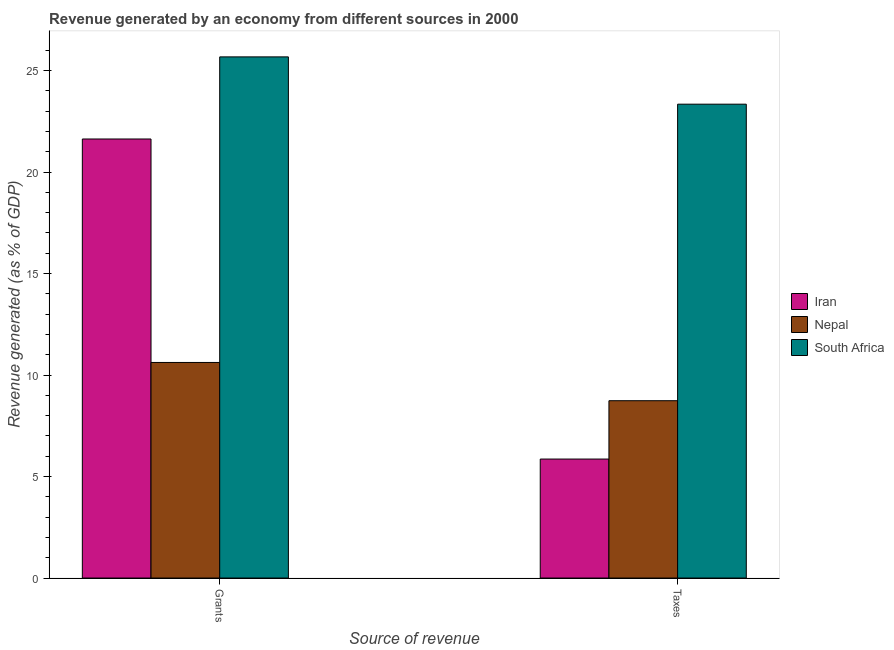Are the number of bars per tick equal to the number of legend labels?
Provide a succinct answer. Yes. How many bars are there on the 2nd tick from the left?
Provide a short and direct response. 3. What is the label of the 1st group of bars from the left?
Provide a short and direct response. Grants. What is the revenue generated by taxes in Iran?
Provide a succinct answer. 5.86. Across all countries, what is the maximum revenue generated by grants?
Provide a short and direct response. 25.67. Across all countries, what is the minimum revenue generated by grants?
Offer a very short reply. 10.62. In which country was the revenue generated by taxes maximum?
Give a very brief answer. South Africa. In which country was the revenue generated by grants minimum?
Make the answer very short. Nepal. What is the total revenue generated by taxes in the graph?
Ensure brevity in your answer.  37.94. What is the difference between the revenue generated by grants in Iran and that in Nepal?
Your response must be concise. 11.01. What is the difference between the revenue generated by taxes in Nepal and the revenue generated by grants in South Africa?
Ensure brevity in your answer.  -16.94. What is the average revenue generated by grants per country?
Keep it short and to the point. 19.31. What is the difference between the revenue generated by taxes and revenue generated by grants in South Africa?
Provide a short and direct response. -2.33. What is the ratio of the revenue generated by grants in South Africa to that in Iran?
Make the answer very short. 1.19. In how many countries, is the revenue generated by taxes greater than the average revenue generated by taxes taken over all countries?
Ensure brevity in your answer.  1. What does the 1st bar from the left in Taxes represents?
Provide a short and direct response. Iran. What does the 2nd bar from the right in Taxes represents?
Provide a short and direct response. Nepal. How many countries are there in the graph?
Make the answer very short. 3. Are the values on the major ticks of Y-axis written in scientific E-notation?
Offer a terse response. No. How many legend labels are there?
Provide a short and direct response. 3. How are the legend labels stacked?
Your response must be concise. Vertical. What is the title of the graph?
Give a very brief answer. Revenue generated by an economy from different sources in 2000. Does "French Polynesia" appear as one of the legend labels in the graph?
Provide a short and direct response. No. What is the label or title of the X-axis?
Offer a terse response. Source of revenue. What is the label or title of the Y-axis?
Your answer should be very brief. Revenue generated (as % of GDP). What is the Revenue generated (as % of GDP) of Iran in Grants?
Your response must be concise. 21.63. What is the Revenue generated (as % of GDP) in Nepal in Grants?
Provide a short and direct response. 10.62. What is the Revenue generated (as % of GDP) of South Africa in Grants?
Your answer should be compact. 25.67. What is the Revenue generated (as % of GDP) of Iran in Taxes?
Keep it short and to the point. 5.86. What is the Revenue generated (as % of GDP) in Nepal in Taxes?
Keep it short and to the point. 8.74. What is the Revenue generated (as % of GDP) in South Africa in Taxes?
Your answer should be compact. 23.34. Across all Source of revenue, what is the maximum Revenue generated (as % of GDP) of Iran?
Ensure brevity in your answer.  21.63. Across all Source of revenue, what is the maximum Revenue generated (as % of GDP) in Nepal?
Make the answer very short. 10.62. Across all Source of revenue, what is the maximum Revenue generated (as % of GDP) in South Africa?
Give a very brief answer. 25.67. Across all Source of revenue, what is the minimum Revenue generated (as % of GDP) of Iran?
Offer a terse response. 5.86. Across all Source of revenue, what is the minimum Revenue generated (as % of GDP) of Nepal?
Provide a succinct answer. 8.74. Across all Source of revenue, what is the minimum Revenue generated (as % of GDP) in South Africa?
Your answer should be very brief. 23.34. What is the total Revenue generated (as % of GDP) in Iran in the graph?
Offer a very short reply. 27.49. What is the total Revenue generated (as % of GDP) of Nepal in the graph?
Offer a very short reply. 19.36. What is the total Revenue generated (as % of GDP) in South Africa in the graph?
Provide a succinct answer. 49.02. What is the difference between the Revenue generated (as % of GDP) in Iran in Grants and that in Taxes?
Give a very brief answer. 15.77. What is the difference between the Revenue generated (as % of GDP) of Nepal in Grants and that in Taxes?
Provide a short and direct response. 1.88. What is the difference between the Revenue generated (as % of GDP) in South Africa in Grants and that in Taxes?
Make the answer very short. 2.33. What is the difference between the Revenue generated (as % of GDP) in Iran in Grants and the Revenue generated (as % of GDP) in Nepal in Taxes?
Make the answer very short. 12.89. What is the difference between the Revenue generated (as % of GDP) in Iran in Grants and the Revenue generated (as % of GDP) in South Africa in Taxes?
Offer a very short reply. -1.71. What is the difference between the Revenue generated (as % of GDP) in Nepal in Grants and the Revenue generated (as % of GDP) in South Africa in Taxes?
Ensure brevity in your answer.  -12.72. What is the average Revenue generated (as % of GDP) of Iran per Source of revenue?
Give a very brief answer. 13.75. What is the average Revenue generated (as % of GDP) of Nepal per Source of revenue?
Your answer should be very brief. 9.68. What is the average Revenue generated (as % of GDP) in South Africa per Source of revenue?
Your answer should be compact. 24.51. What is the difference between the Revenue generated (as % of GDP) of Iran and Revenue generated (as % of GDP) of Nepal in Grants?
Your response must be concise. 11.01. What is the difference between the Revenue generated (as % of GDP) in Iran and Revenue generated (as % of GDP) in South Africa in Grants?
Make the answer very short. -4.04. What is the difference between the Revenue generated (as % of GDP) in Nepal and Revenue generated (as % of GDP) in South Africa in Grants?
Make the answer very short. -15.05. What is the difference between the Revenue generated (as % of GDP) in Iran and Revenue generated (as % of GDP) in Nepal in Taxes?
Your answer should be compact. -2.87. What is the difference between the Revenue generated (as % of GDP) of Iran and Revenue generated (as % of GDP) of South Africa in Taxes?
Your answer should be very brief. -17.48. What is the difference between the Revenue generated (as % of GDP) of Nepal and Revenue generated (as % of GDP) of South Africa in Taxes?
Your answer should be compact. -14.61. What is the ratio of the Revenue generated (as % of GDP) in Iran in Grants to that in Taxes?
Offer a terse response. 3.69. What is the ratio of the Revenue generated (as % of GDP) of Nepal in Grants to that in Taxes?
Keep it short and to the point. 1.22. What is the ratio of the Revenue generated (as % of GDP) of South Africa in Grants to that in Taxes?
Offer a very short reply. 1.1. What is the difference between the highest and the second highest Revenue generated (as % of GDP) of Iran?
Provide a short and direct response. 15.77. What is the difference between the highest and the second highest Revenue generated (as % of GDP) in Nepal?
Your answer should be very brief. 1.88. What is the difference between the highest and the second highest Revenue generated (as % of GDP) in South Africa?
Offer a terse response. 2.33. What is the difference between the highest and the lowest Revenue generated (as % of GDP) of Iran?
Make the answer very short. 15.77. What is the difference between the highest and the lowest Revenue generated (as % of GDP) of Nepal?
Keep it short and to the point. 1.88. What is the difference between the highest and the lowest Revenue generated (as % of GDP) of South Africa?
Offer a very short reply. 2.33. 